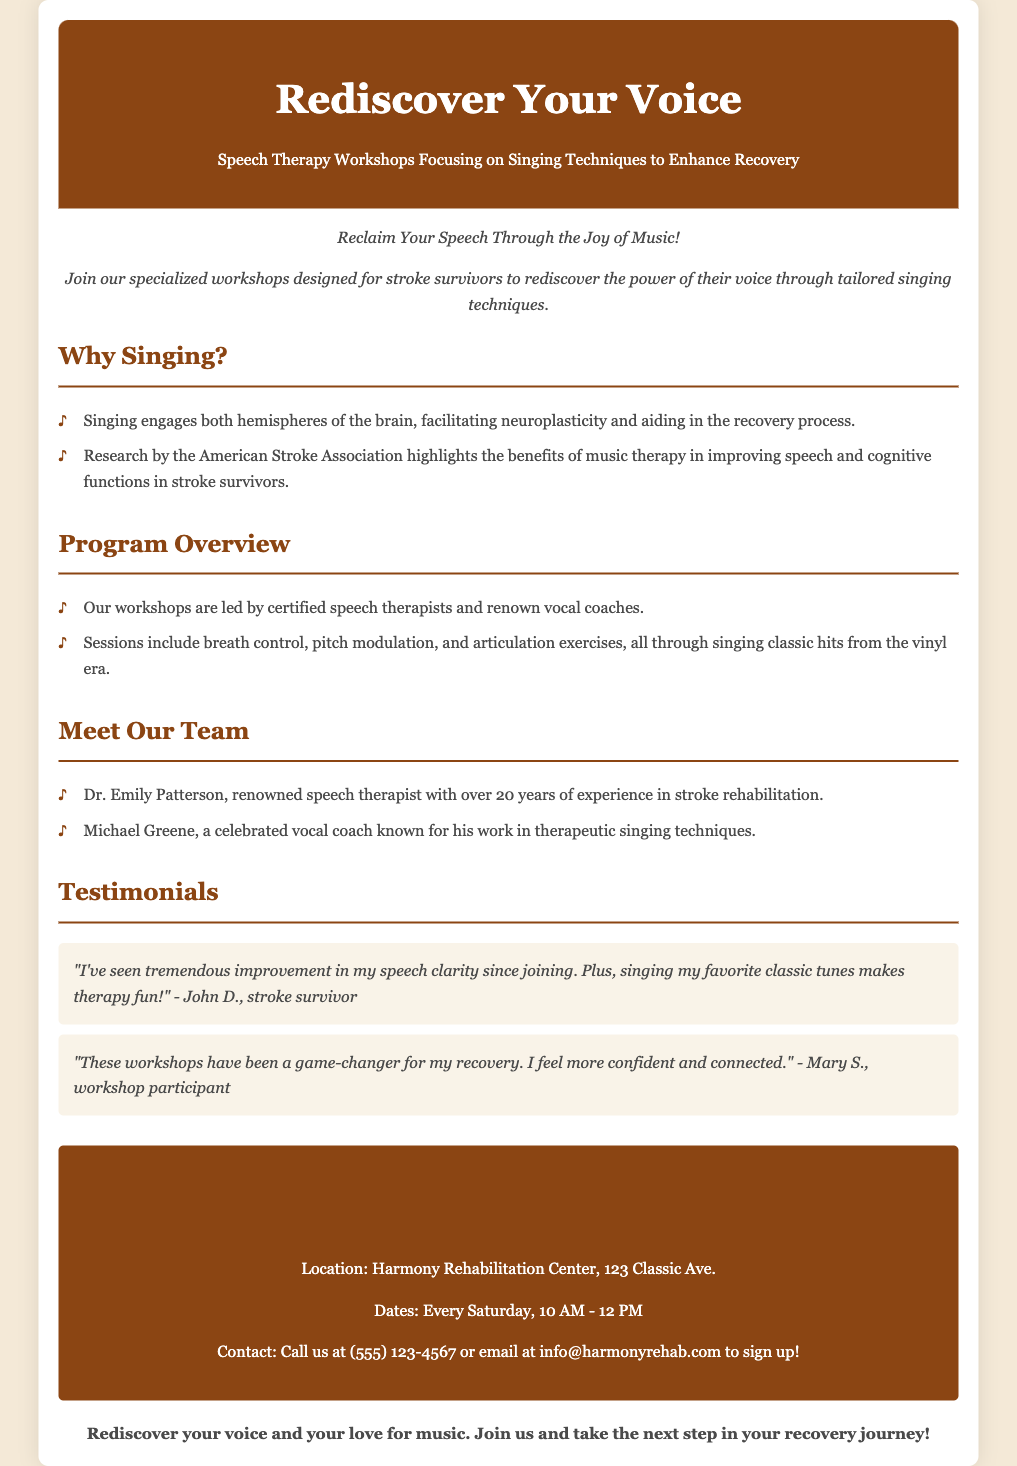What is the name of the program? The program is titled "Rediscover Your Voice: Speech Therapy Workshops Focusing on Singing Techniques to Enhance Recovery."
Answer: Rediscover Your Voice Who are the workshop leaders? The workshop leaders include Dr. Emily Patterson and Michael Greene.
Answer: Dr. Emily Patterson, Michael Greene What time do the workshops take place? The workshops are scheduled for every Saturday from 10 AM to 12 PM.
Answer: 10 AM - 12 PM What is the location of the workshops? The workshops are held at Harmony Rehabilitation Center, 123 Classic Ave.
Answer: Harmony Rehabilitation Center, 123 Classic Ave What unique aspect of therapy do the workshops focus on? The workshops focus on singing techniques to enhance recovery.
Answer: Singing techniques What is one benefit of singing mentioned in the document? One benefit is that singing engages both hemispheres of the brain, facilitating neuroplasticity.
Answer: Neuroplasticity How often do the workshops occur? The document states that the workshops occur every Saturday.
Answer: Every Saturday What does Dr. Emily Patterson specialize in? Dr. Emily Patterson specializes in stroke rehabilitation.
Answer: Stroke rehabilitation 